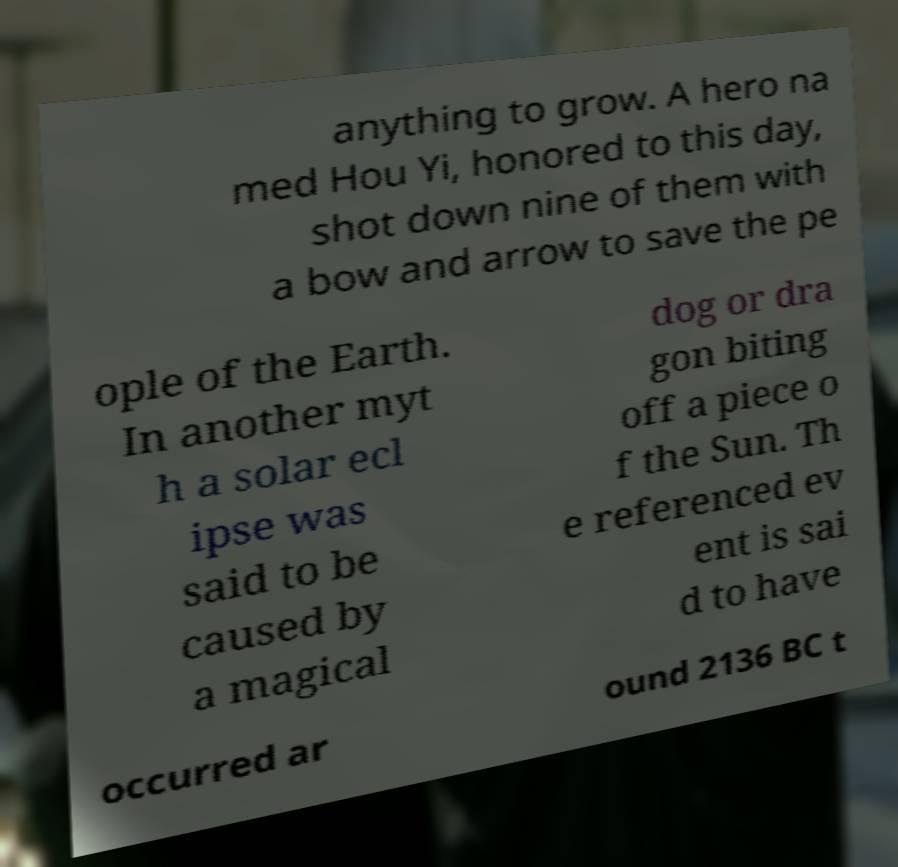Please read and relay the text visible in this image. What does it say? anything to grow. A hero na med Hou Yi, honored to this day, shot down nine of them with a bow and arrow to save the pe ople of the Earth. In another myt h a solar ecl ipse was said to be caused by a magical dog or dra gon biting off a piece o f the Sun. Th e referenced ev ent is sai d to have occurred ar ound 2136 BC t 